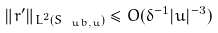Convert formula to latex. <formula><loc_0><loc_0><loc_500><loc_500>\| r ^ { \prime } \| _ { L ^ { 2 } ( S _ { \ u b , u } ) } \leq O ( \delta ^ { - 1 } | u | ^ { - 3 } )</formula> 